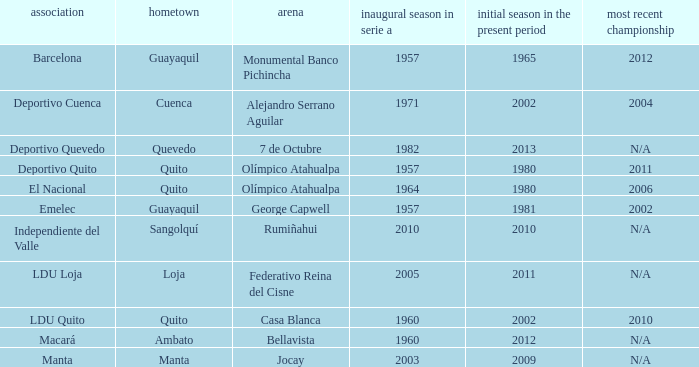Name the most for first season in the serie a for 7 de octubre 1982.0. 